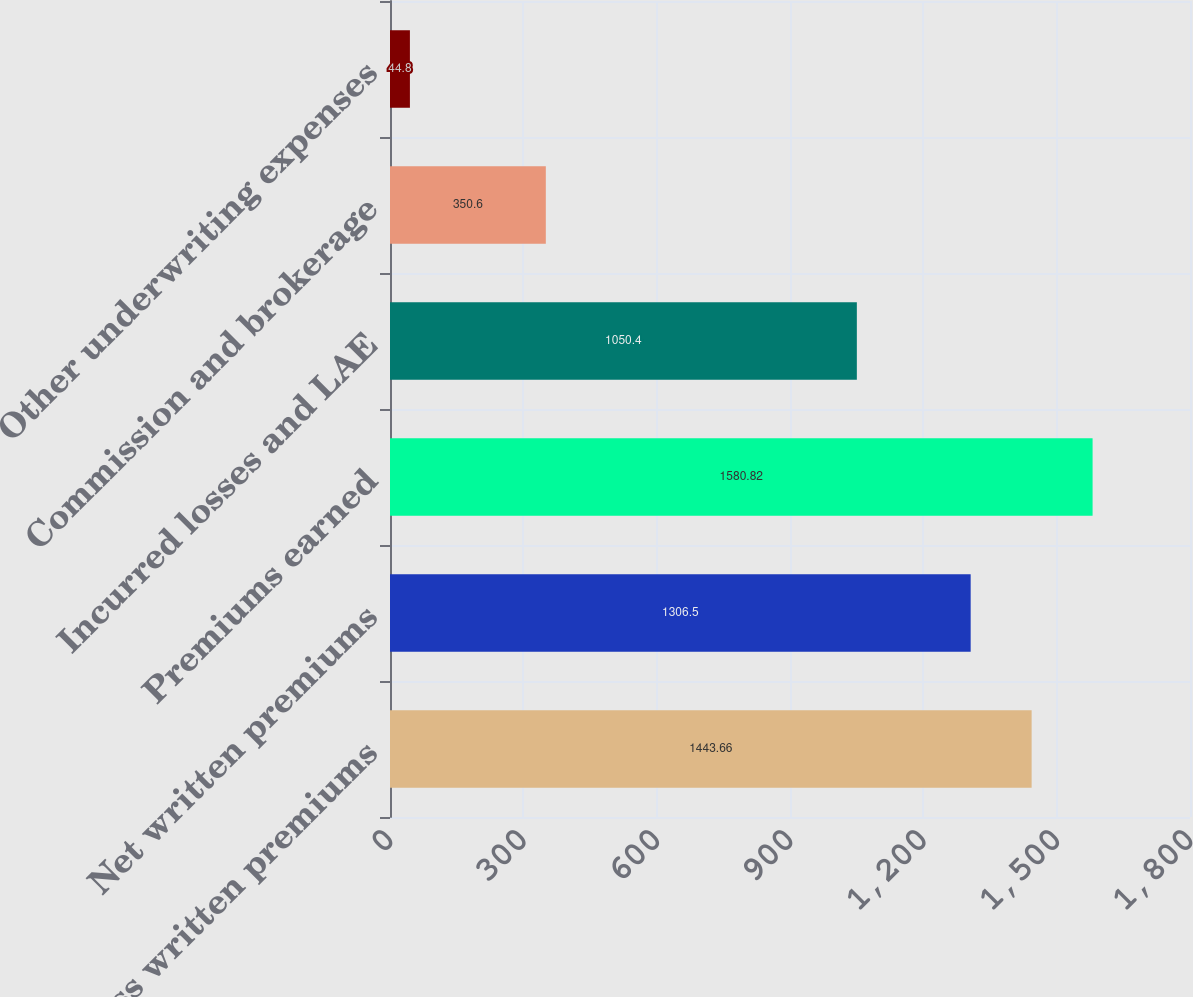Convert chart. <chart><loc_0><loc_0><loc_500><loc_500><bar_chart><fcel>Gross written premiums<fcel>Net written premiums<fcel>Premiums earned<fcel>Incurred losses and LAE<fcel>Commission and brokerage<fcel>Other underwriting expenses<nl><fcel>1443.66<fcel>1306.5<fcel>1580.82<fcel>1050.4<fcel>350.6<fcel>44.8<nl></chart> 